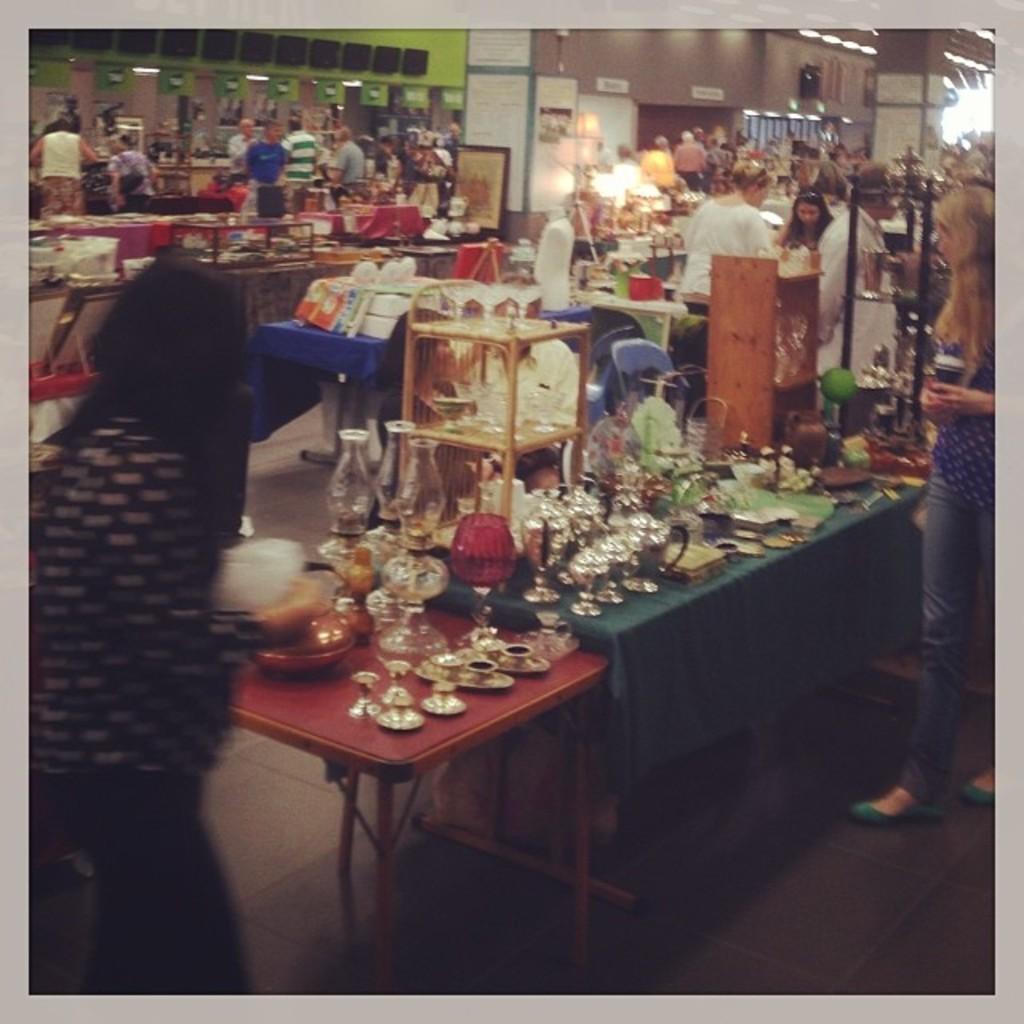How many people are in the image? There is a group of people in the image, but the exact number is not specified. What are the people doing in the image? The people are standing and looking at items on a table. What objects can be seen on the table? There is a lamp, shields, and steel on the table. What can be seen in the background of the image? There is a wall and a pillar in the background of the image. What type of shoes are the people wearing in the image? There is no information about shoes in the image; the focus is on the people looking at items on the table. What kind of music can be heard in the background of the image? There is no mention of music in the image; the background elements are a wall and a pillar. 